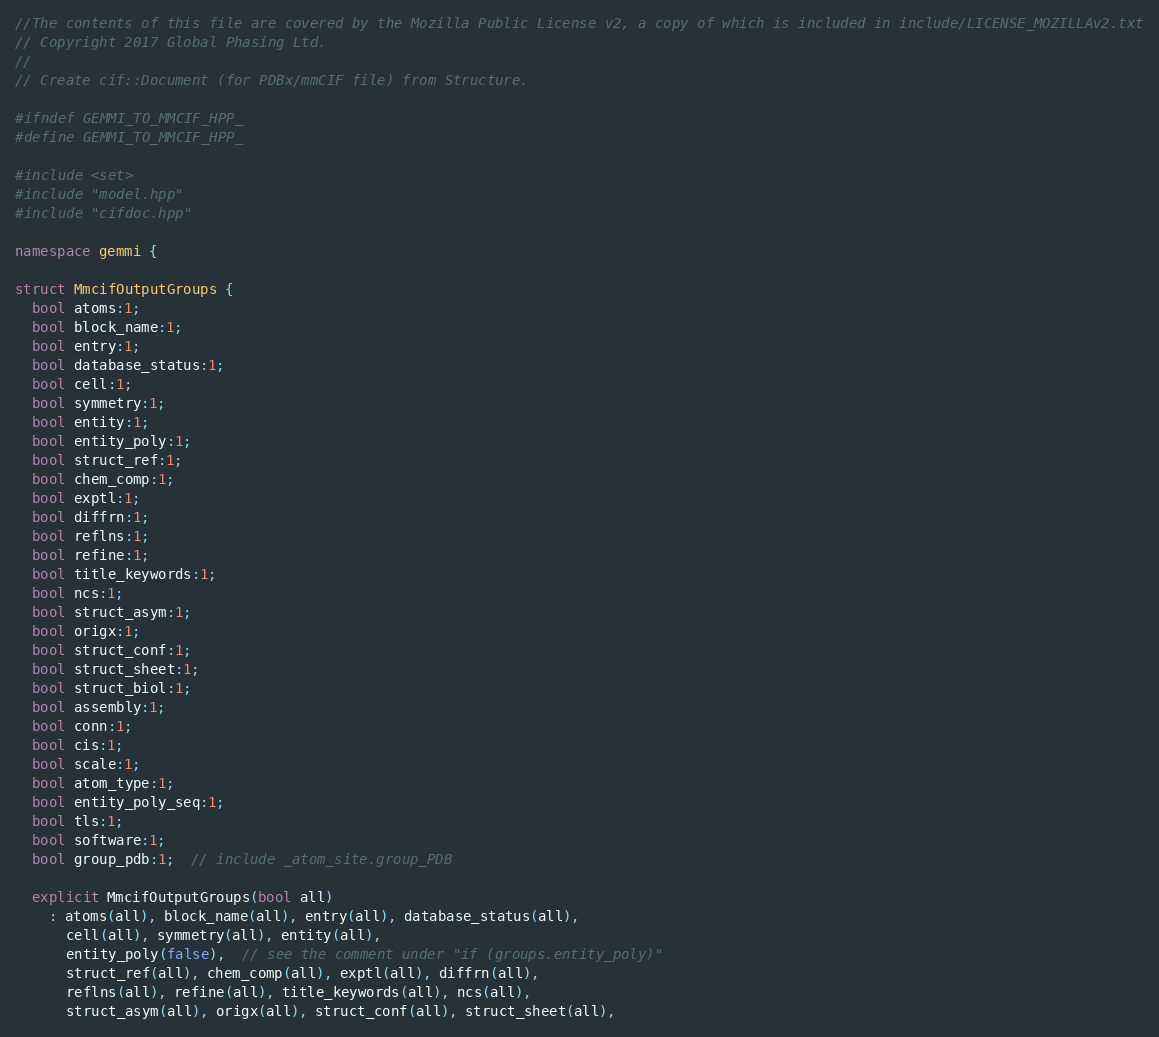Convert code to text. <code><loc_0><loc_0><loc_500><loc_500><_C++_>//The contents of this file are covered by the Mozilla Public License v2, a copy of which is included in include/LICENSE_MOZILLAv2.txt
// Copyright 2017 Global Phasing Ltd.
//
// Create cif::Document (for PDBx/mmCIF file) from Structure.

#ifndef GEMMI_TO_MMCIF_HPP_
#define GEMMI_TO_MMCIF_HPP_

#include <set>
#include "model.hpp"
#include "cifdoc.hpp"

namespace gemmi {

struct MmcifOutputGroups {
  bool atoms:1;
  bool block_name:1;
  bool entry:1;
  bool database_status:1;
  bool cell:1;
  bool symmetry:1;
  bool entity:1;
  bool entity_poly:1;
  bool struct_ref:1;
  bool chem_comp:1;
  bool exptl:1;
  bool diffrn:1;
  bool reflns:1;
  bool refine:1;
  bool title_keywords:1;
  bool ncs:1;
  bool struct_asym:1;
  bool origx:1;
  bool struct_conf:1;
  bool struct_sheet:1;
  bool struct_biol:1;
  bool assembly:1;
  bool conn:1;
  bool cis:1;
  bool scale:1;
  bool atom_type:1;
  bool entity_poly_seq:1;
  bool tls:1;
  bool software:1;
  bool group_pdb:1;  // include _atom_site.group_PDB

  explicit MmcifOutputGroups(bool all)
    : atoms(all), block_name(all), entry(all), database_status(all),
      cell(all), symmetry(all), entity(all),
      entity_poly(false),  // see the comment under "if (groups.entity_poly)"
      struct_ref(all), chem_comp(all), exptl(all), diffrn(all),
      reflns(all), refine(all), title_keywords(all), ncs(all),
      struct_asym(all), origx(all), struct_conf(all), struct_sheet(all),</code> 